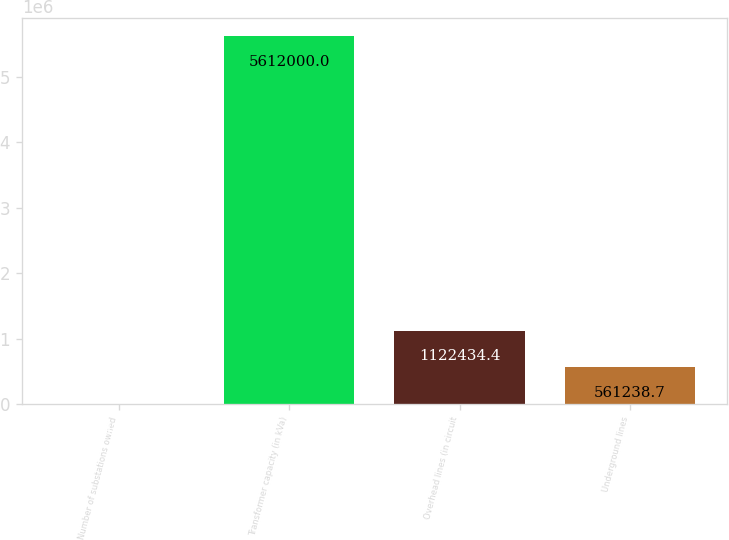Convert chart. <chart><loc_0><loc_0><loc_500><loc_500><bar_chart><fcel>Number of substations owned<fcel>Transformer capacity (in kVa)<fcel>Overhead lines (in circuit<fcel>Underground lines<nl><fcel>43<fcel>5.612e+06<fcel>1.12243e+06<fcel>561239<nl></chart> 